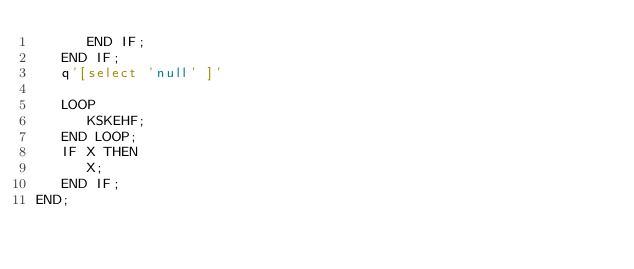<code> <loc_0><loc_0><loc_500><loc_500><_SQL_>      END IF;
   END IF;
   q'[select 'null' ]'

   LOOP
      KSKEHF;
   END LOOP;
   IF X THEN
      X;
   END IF;
END;</code> 